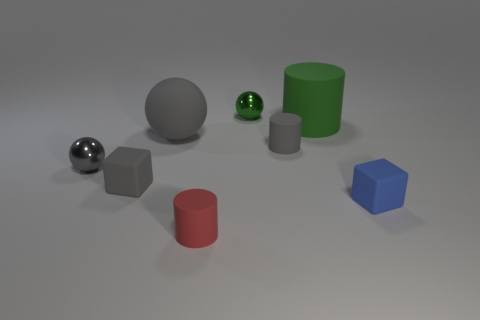Add 1 gray rubber balls. How many objects exist? 9 Subtract all cylinders. How many objects are left? 5 Subtract all small blue metallic cubes. Subtract all matte cubes. How many objects are left? 6 Add 2 green spheres. How many green spheres are left? 3 Add 2 red things. How many red things exist? 3 Subtract 0 yellow cylinders. How many objects are left? 8 